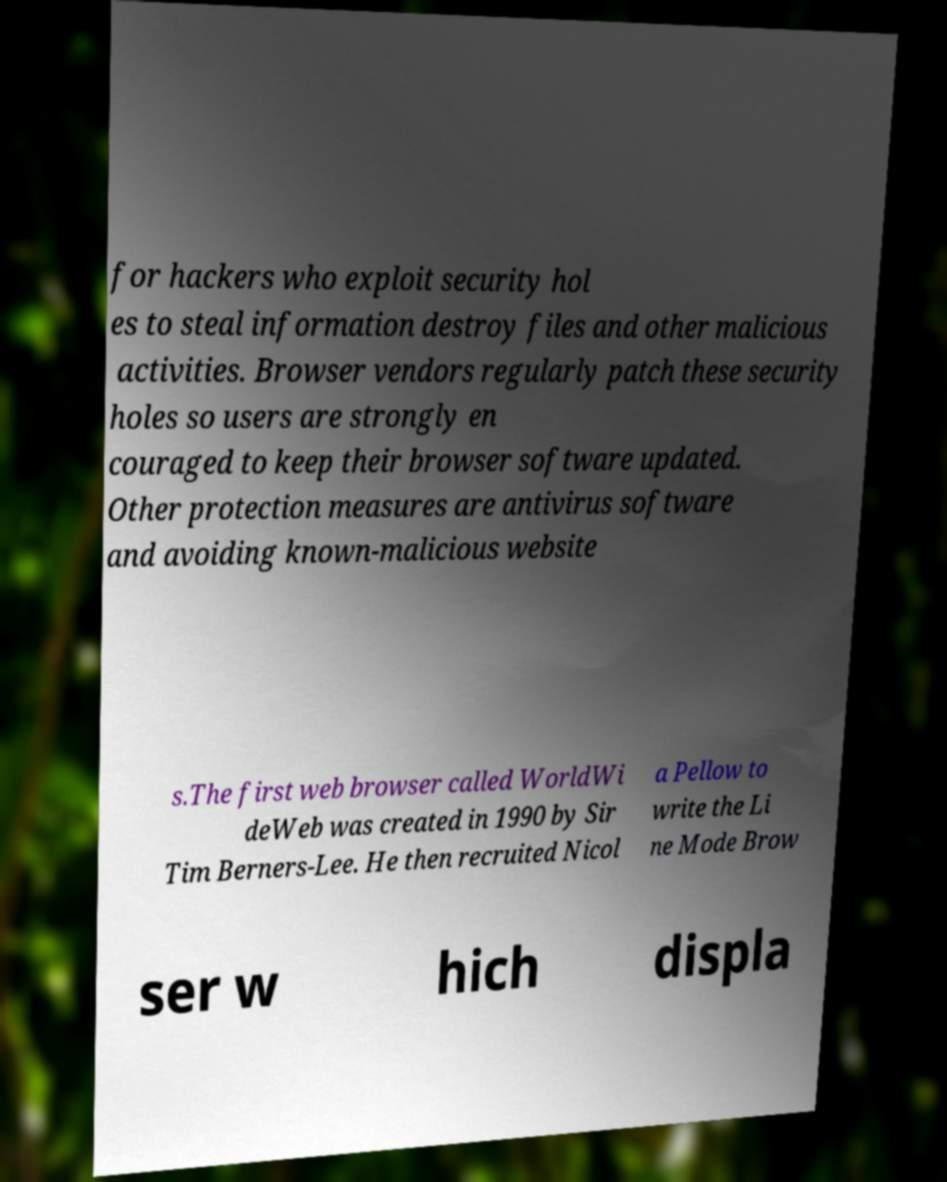Please identify and transcribe the text found in this image. for hackers who exploit security hol es to steal information destroy files and other malicious activities. Browser vendors regularly patch these security holes so users are strongly en couraged to keep their browser software updated. Other protection measures are antivirus software and avoiding known-malicious website s.The first web browser called WorldWi deWeb was created in 1990 by Sir Tim Berners-Lee. He then recruited Nicol a Pellow to write the Li ne Mode Brow ser w hich displa 